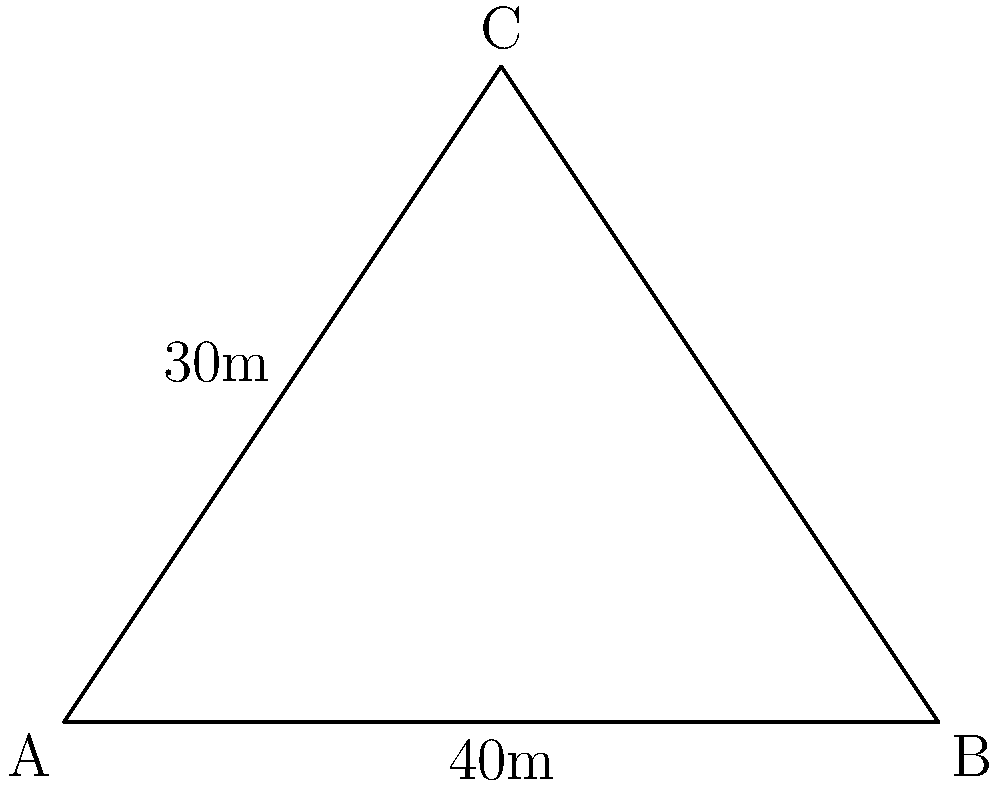During a training session at Naomh Fionnbarra GAA Club, three players form a triangular formation on the pitch. Player A is at one corner of the formation, player B is 40 meters away from A along the sideline, and player C is 30 meters away from A at a right angle to the sideline. What is the area of the triangular formation formed by these three players? Let's approach this step-by-step:

1) We can see that this forms a right-angled triangle, with the right angle at A.

2) We're given two sides of this triangle:
   - The base (AB) is 40 meters
   - The height (AC) is 30 meters

3) The formula for the area of a triangle is:

   $$Area = \frac{1}{2} \times base \times height$$

4) Substituting our values:

   $$Area = \frac{1}{2} \times 40 \times 30$$

5) Let's calculate:
   $$Area = \frac{1}{2} \times 1200 = 600$$

Therefore, the area of the triangular formation is 600 square meters.
Answer: 600 square meters 